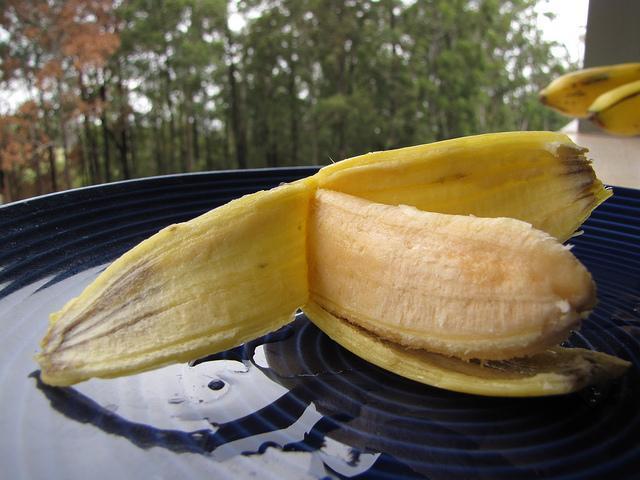How many bananas are there?
Give a very brief answer. 2. 